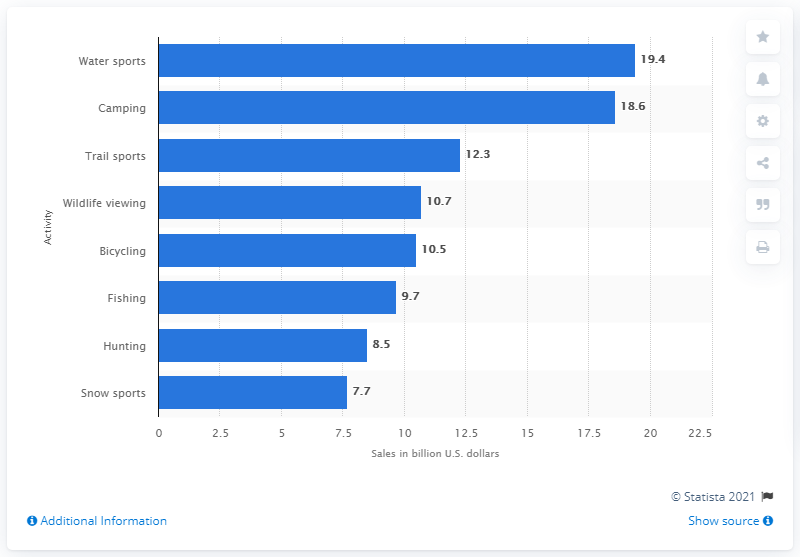Point out several critical features in this image. In the United States in 2012, fishing equipment sales generated approximately $9.7 billion. 